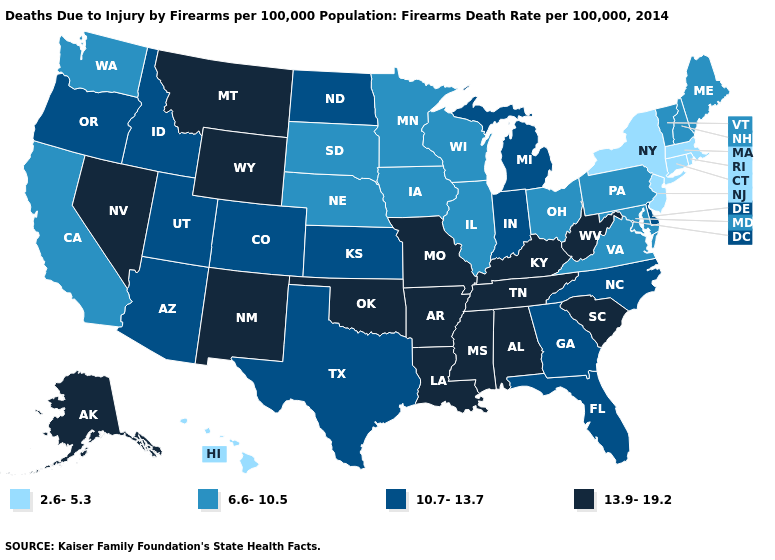What is the value of Hawaii?
Quick response, please. 2.6-5.3. Does the map have missing data?
Answer briefly. No. Among the states that border Arkansas , does Texas have the highest value?
Quick response, please. No. What is the lowest value in states that border Virginia?
Write a very short answer. 6.6-10.5. Is the legend a continuous bar?
Concise answer only. No. What is the highest value in the USA?
Be succinct. 13.9-19.2. What is the value of Washington?
Write a very short answer. 6.6-10.5. What is the value of North Dakota?
Answer briefly. 10.7-13.7. Which states have the lowest value in the USA?
Short answer required. Connecticut, Hawaii, Massachusetts, New Jersey, New York, Rhode Island. Among the states that border Kentucky , does Illinois have the lowest value?
Give a very brief answer. Yes. Does Indiana have a lower value than Nevada?
Keep it brief. Yes. Among the states that border Rhode Island , which have the highest value?
Concise answer only. Connecticut, Massachusetts. How many symbols are there in the legend?
Concise answer only. 4. Among the states that border Wyoming , which have the lowest value?
Be succinct. Nebraska, South Dakota. What is the lowest value in the Northeast?
Write a very short answer. 2.6-5.3. 